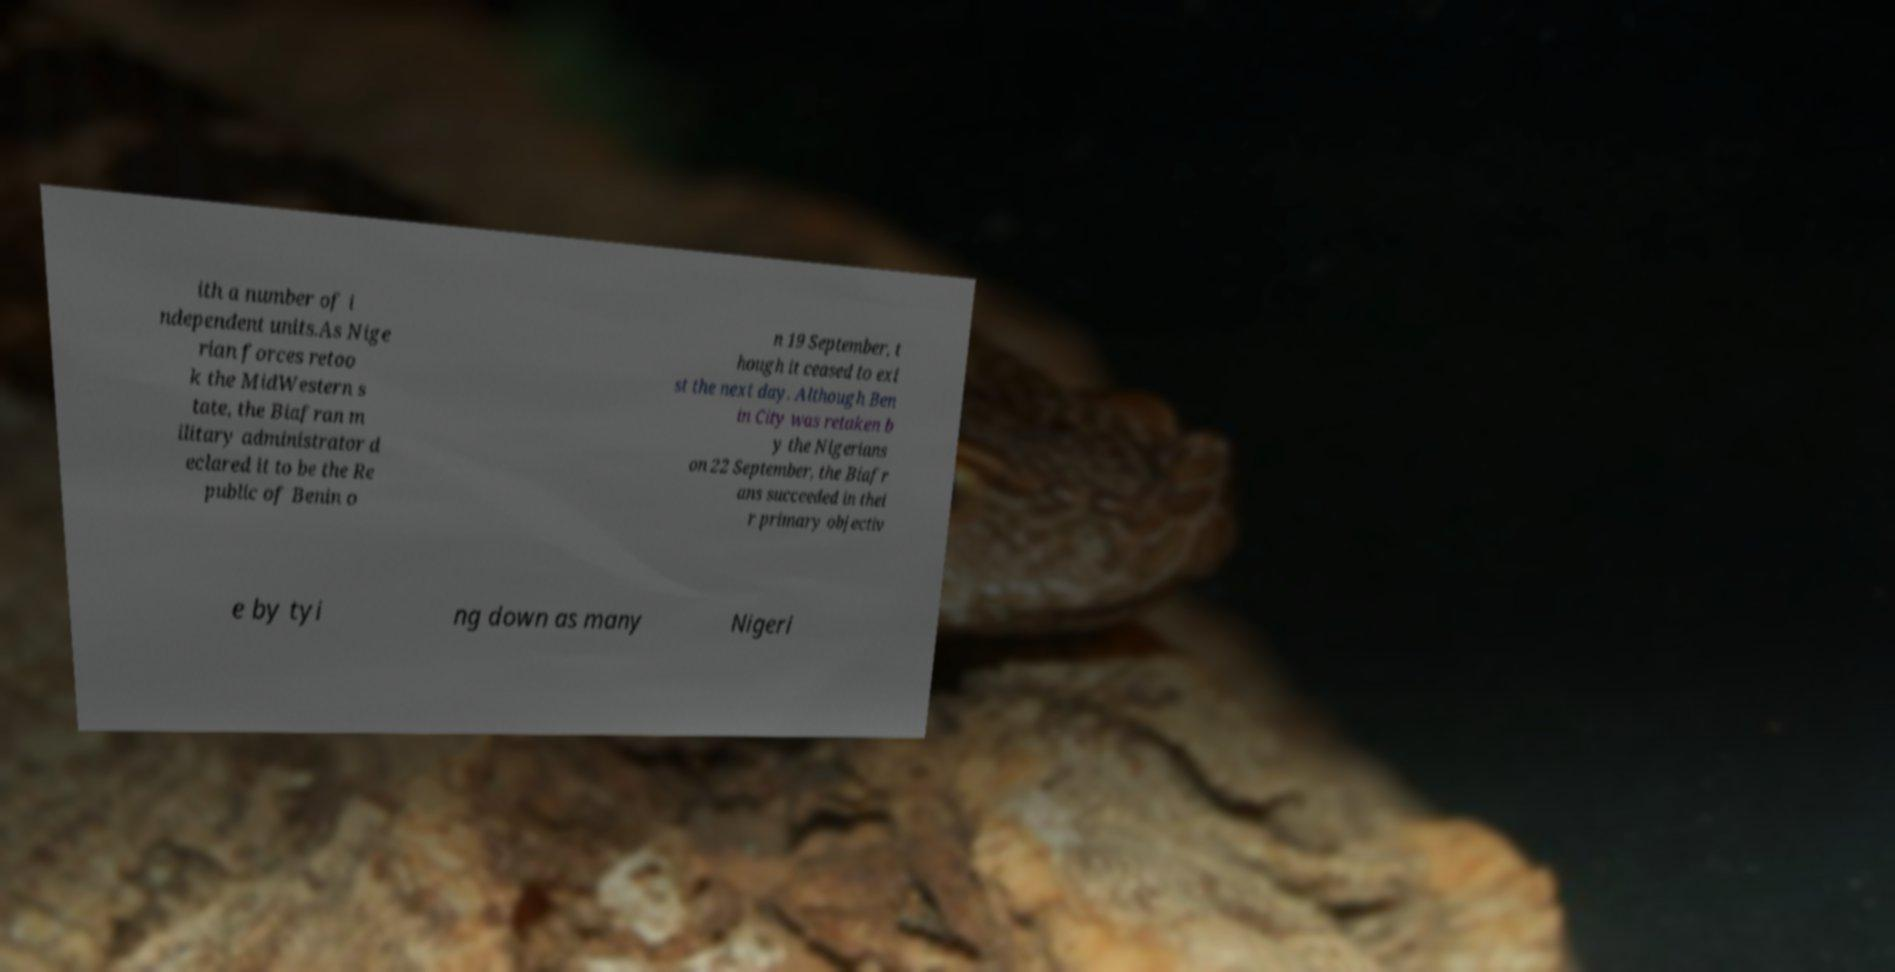Can you accurately transcribe the text from the provided image for me? ith a number of i ndependent units.As Nige rian forces retoo k the MidWestern s tate, the Biafran m ilitary administrator d eclared it to be the Re public of Benin o n 19 September, t hough it ceased to exi st the next day. Although Ben in City was retaken b y the Nigerians on 22 September, the Biafr ans succeeded in thei r primary objectiv e by tyi ng down as many Nigeri 